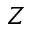<formula> <loc_0><loc_0><loc_500><loc_500>Z</formula> 